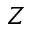<formula> <loc_0><loc_0><loc_500><loc_500>Z</formula> 